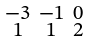<formula> <loc_0><loc_0><loc_500><loc_500>\begin{smallmatrix} - 3 & - 1 & 0 \\ 1 & 1 & 2 \end{smallmatrix}</formula> 